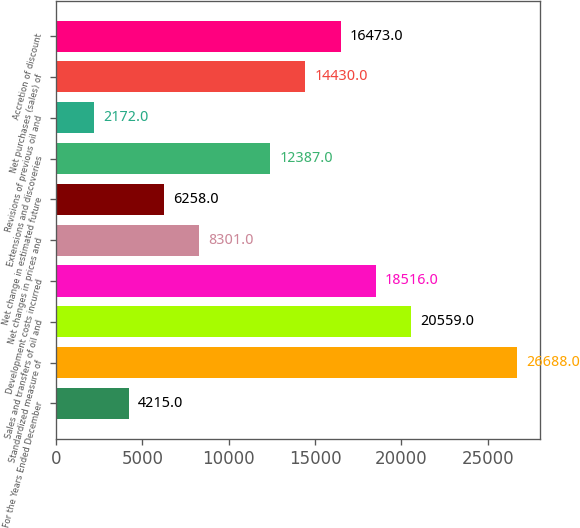<chart> <loc_0><loc_0><loc_500><loc_500><bar_chart><fcel>For the Years Ended December<fcel>Standardized measure of<fcel>Sales and transfers of oil and<fcel>Development costs incurred<fcel>Net changes in prices and<fcel>Net change in estimated future<fcel>Extensions and discoveries<fcel>Revisions of previous oil and<fcel>Net purchases (sales) of<fcel>Accretion of discount<nl><fcel>4215<fcel>26688<fcel>20559<fcel>18516<fcel>8301<fcel>6258<fcel>12387<fcel>2172<fcel>14430<fcel>16473<nl></chart> 